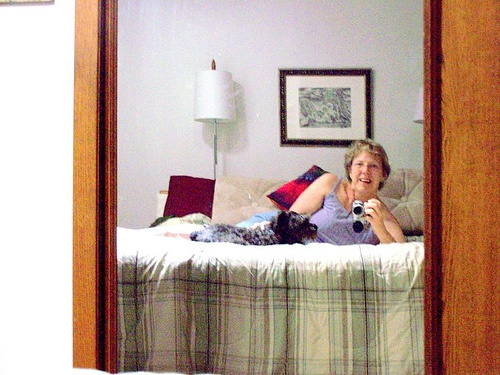Describe the objects in this image and their specific colors. I can see bed in beige, white, gray, and darkgray tones, people in beige, tan, brown, and darkgray tones, and dog in beige, black, darkgray, gray, and lavender tones in this image. 